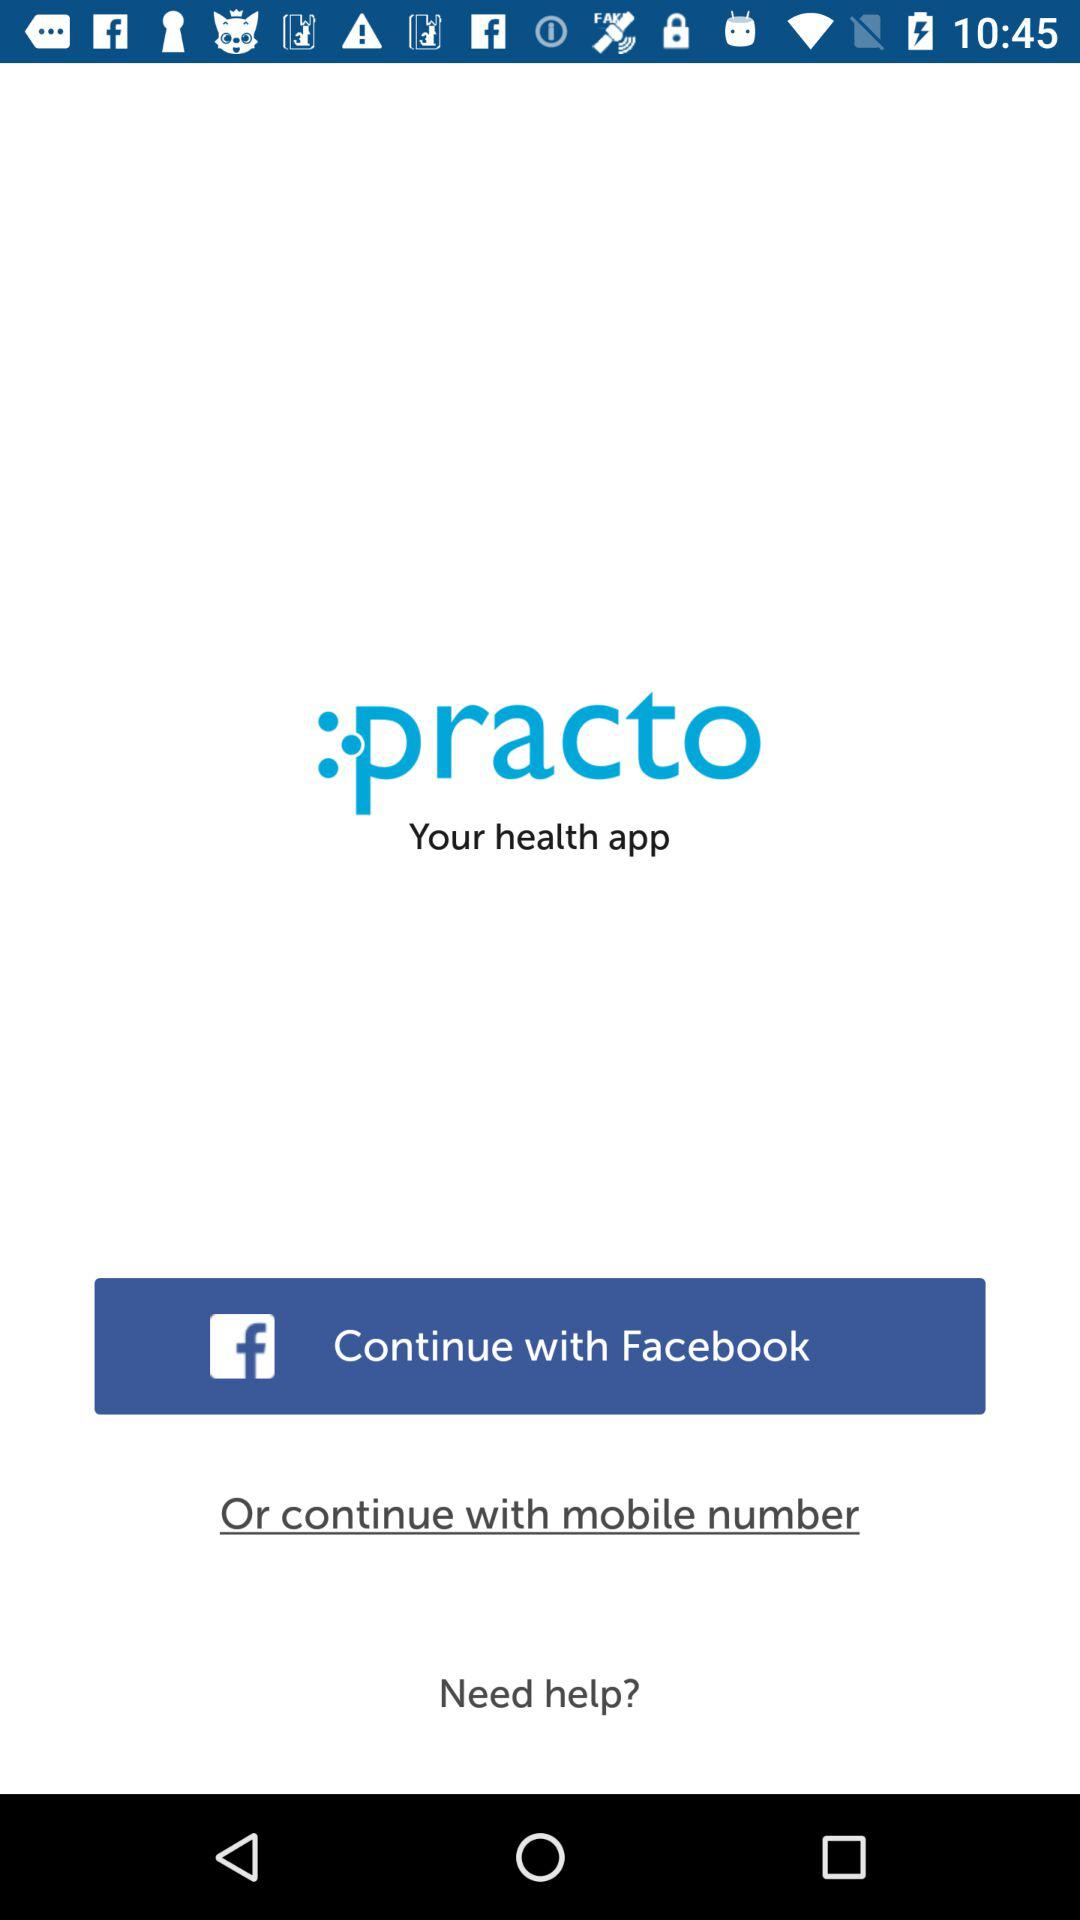What application can be used for login? The application is "Facebook". 